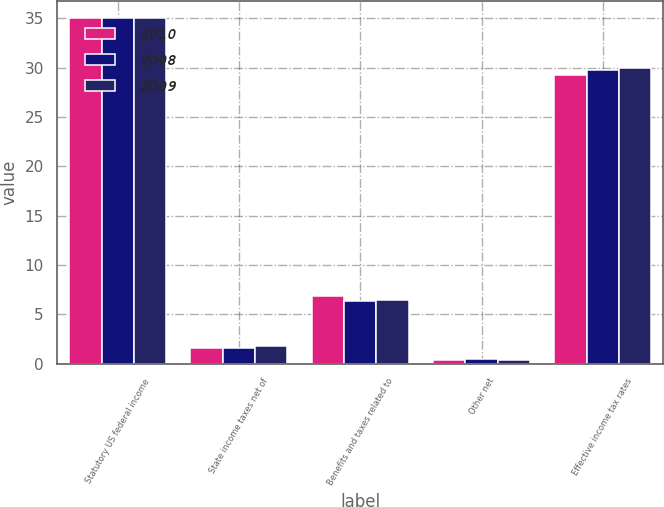<chart> <loc_0><loc_0><loc_500><loc_500><stacked_bar_chart><ecel><fcel>Statutory US federal income<fcel>State income taxes net of<fcel>Benefits and taxes related to<fcel>Other net<fcel>Effective income tax rates<nl><fcel>2010<fcel>35<fcel>1.6<fcel>6.9<fcel>0.4<fcel>29.3<nl><fcel>2008<fcel>35<fcel>1.6<fcel>6.3<fcel>0.5<fcel>29.8<nl><fcel>2009<fcel>35<fcel>1.8<fcel>6.4<fcel>0.4<fcel>30<nl></chart> 